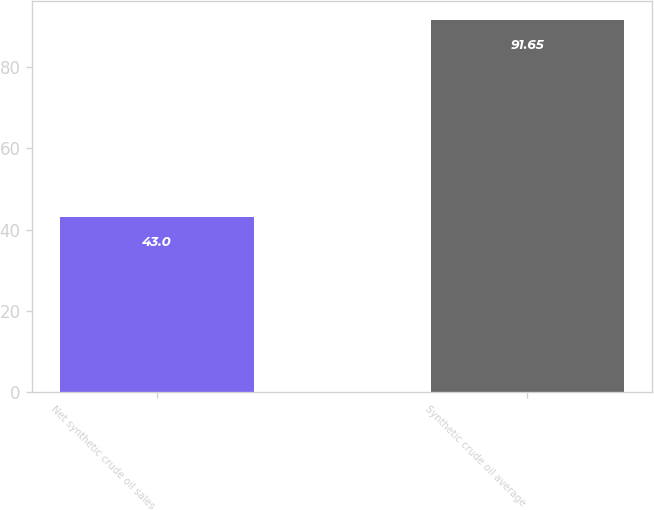Convert chart. <chart><loc_0><loc_0><loc_500><loc_500><bar_chart><fcel>Net synthetic crude oil sales<fcel>Synthetic crude oil average<nl><fcel>43<fcel>91.65<nl></chart> 